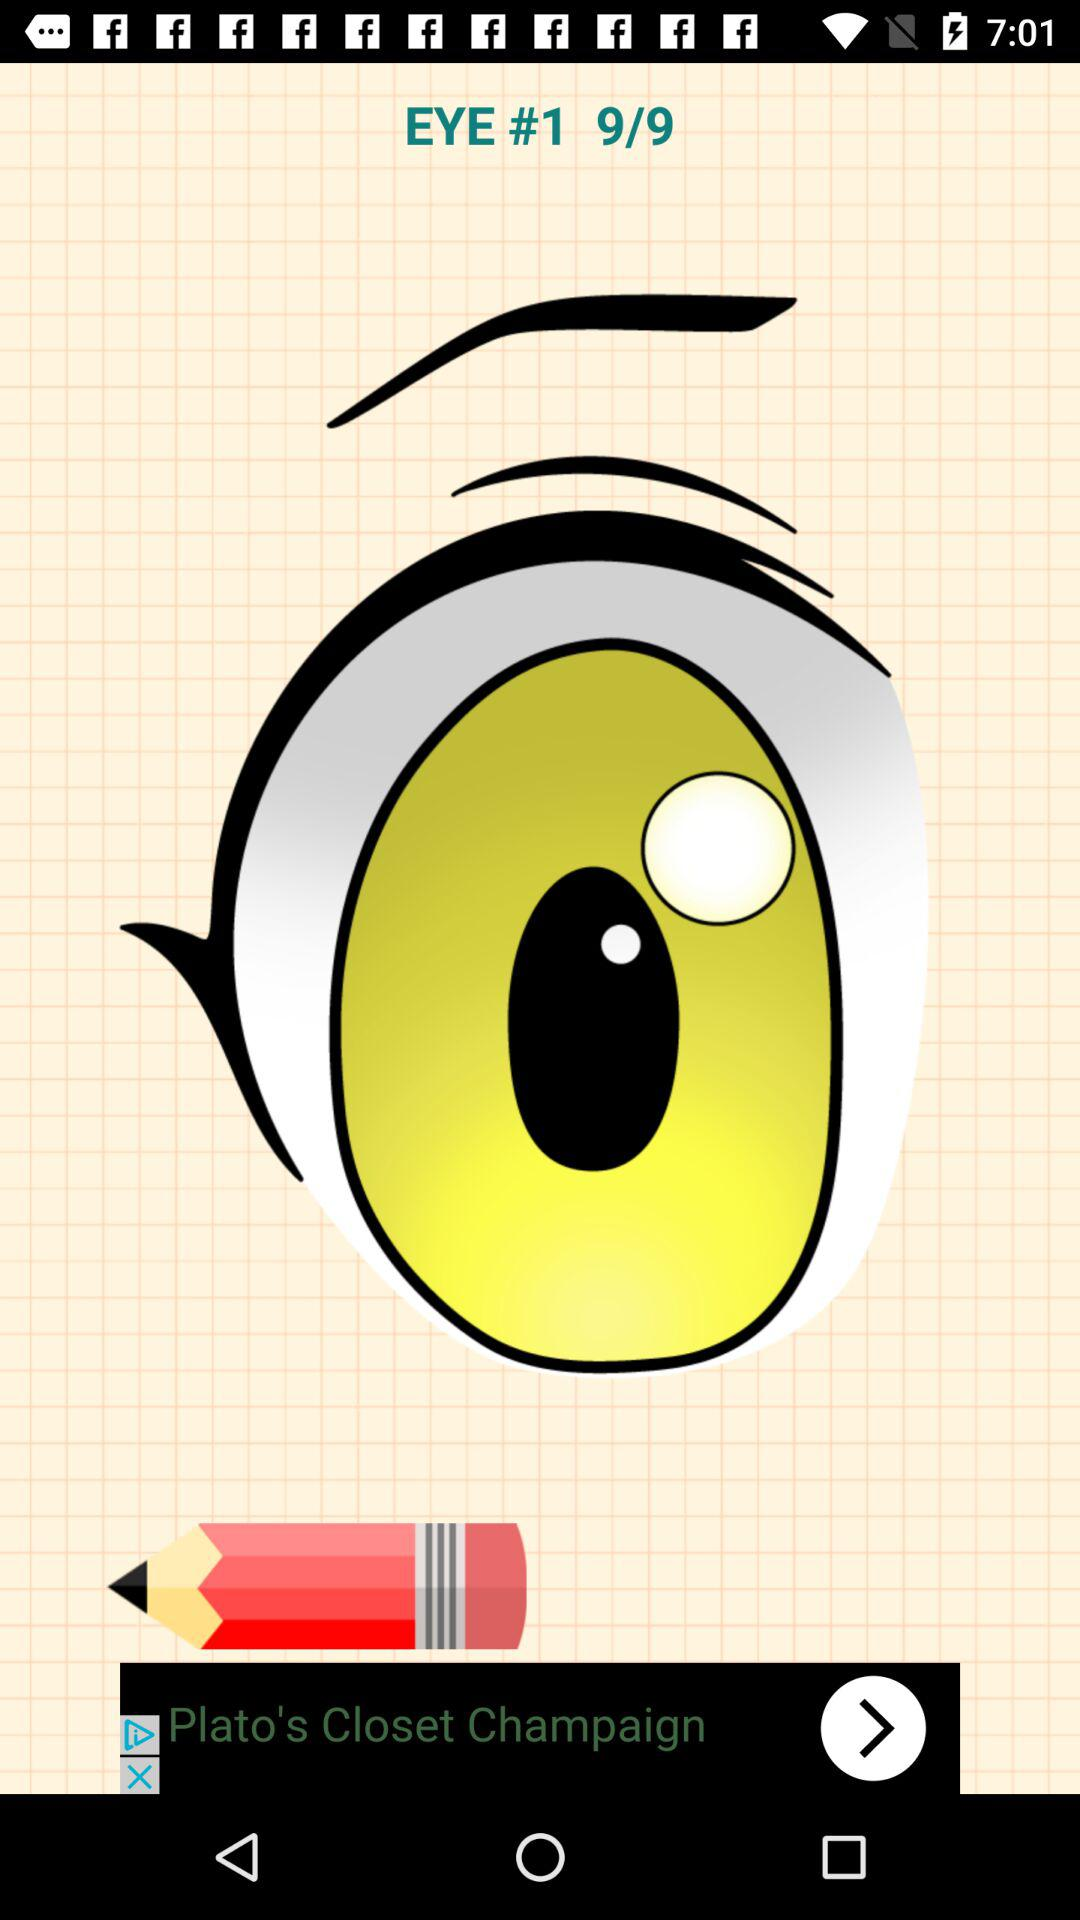How many pages in total are there? There are 9 pages in total. 